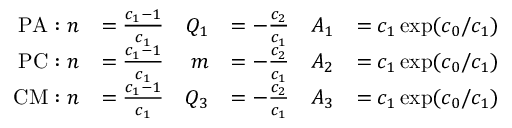Convert formula to latex. <formula><loc_0><loc_0><loc_500><loc_500>\begin{array} { r l r l r l } { P A \colon n } & { = \frac { c _ { 1 } - 1 } { c _ { 1 } } } & { Q _ { 1 } } & { = - \frac { c _ { 2 } } { c _ { 1 } } } & { A _ { 1 } } & { = c _ { 1 } \exp ( c _ { 0 } / c _ { 1 } ) } \\ { P C \colon n } & { = \frac { c _ { 1 } - 1 } { c _ { 1 } } } & { m } & { = - \frac { c _ { 2 } } { c _ { 1 } } } & { A _ { 2 } } & { = c _ { 1 } \exp ( c _ { 0 } / c _ { 1 } ) } \\ { C M \colon n } & { = \frac { c _ { 1 } - 1 } { c _ { 1 } } } & { Q _ { 3 } } & { = - \frac { c _ { 2 } } { c _ { 1 } } } & { A _ { 3 } } & { = c _ { 1 } \exp ( c _ { 0 } / c _ { 1 } ) } \end{array}</formula> 